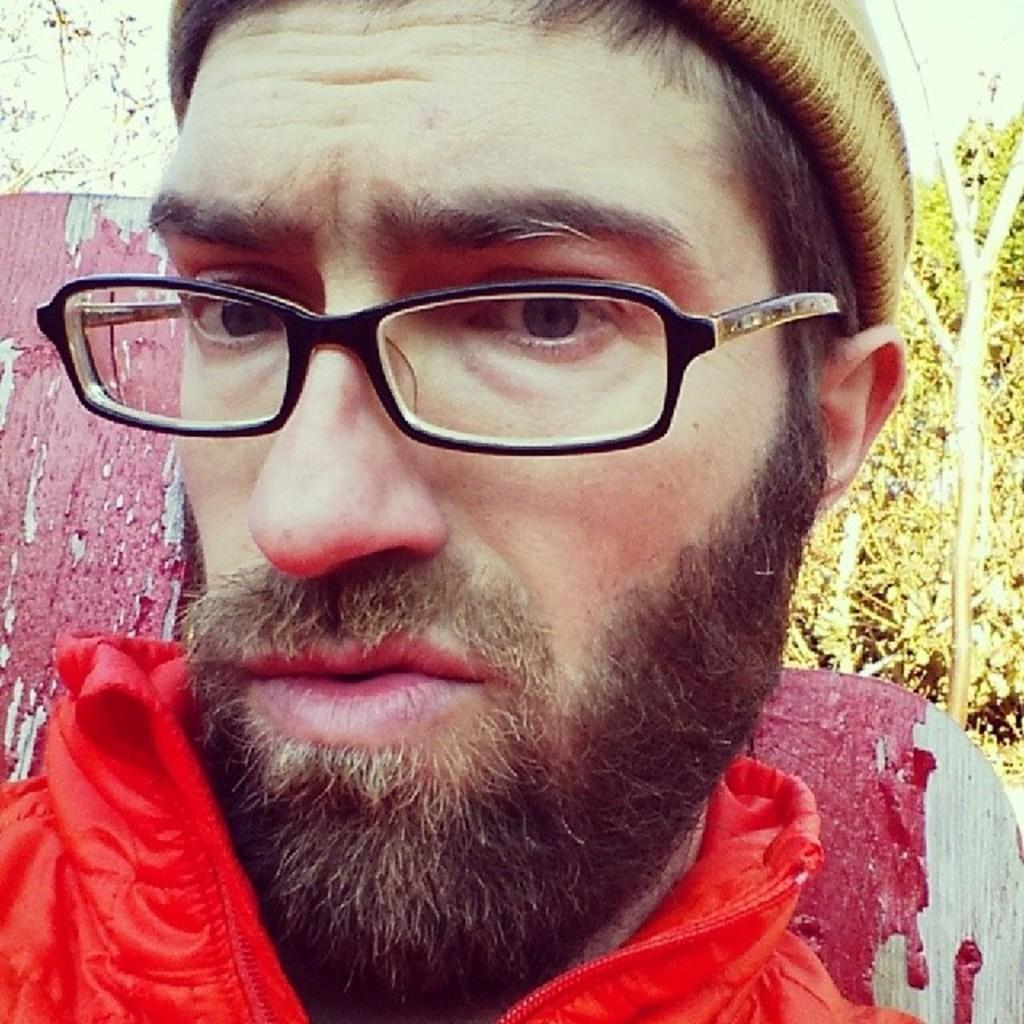What is the appearance of the man in the image? The man has a beard and mustache, and he is wearing a cap, spectacles, and a red jacket. What can be seen in the background of the image? There are trees visible in the image. What object with red paint can be seen in the image? There is a wooden board with red paint in the image. What is the man's reaction to the hopeful event happening in the hall? There is no mention of a hall, hopeful event, or the man's reaction in the image. 